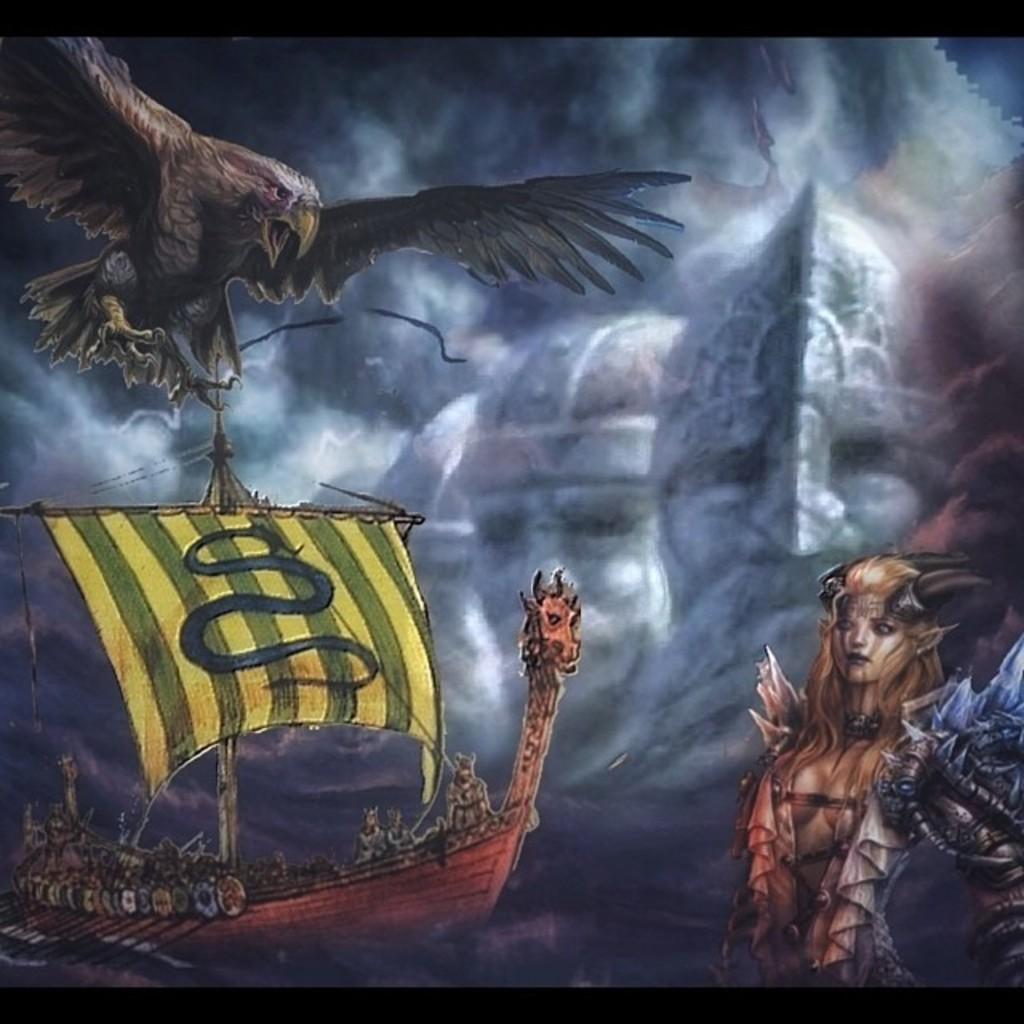How would you summarize this image in a sentence or two? This looks like an animated image. I can see an eagle flying. This is a dragon shaped boat with paddles on the water. This is the woman with horns. In the background, I can see the faces of two people in the clouds. 